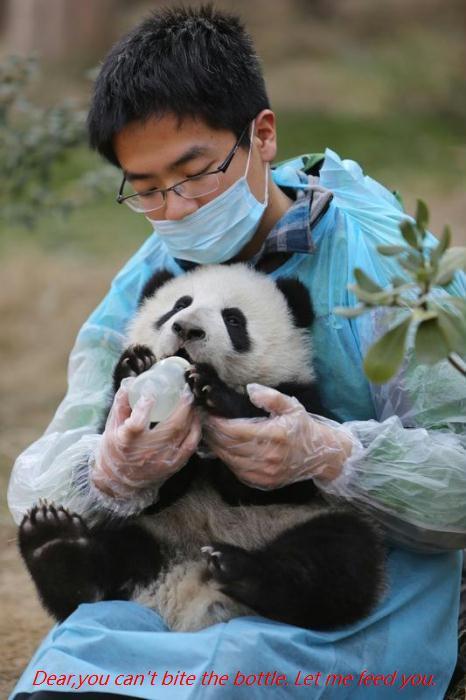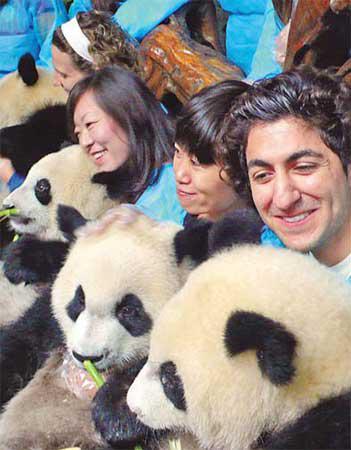The first image is the image on the left, the second image is the image on the right. Analyze the images presented: Is the assertion "One of the pandas is being fed a bottle by a person wearing a protective blue garment." valid? Answer yes or no. Yes. The first image is the image on the left, the second image is the image on the right. Evaluate the accuracy of this statement regarding the images: "In one of the images, there are least two people interacting with a panda bear.". Is it true? Answer yes or no. Yes. 